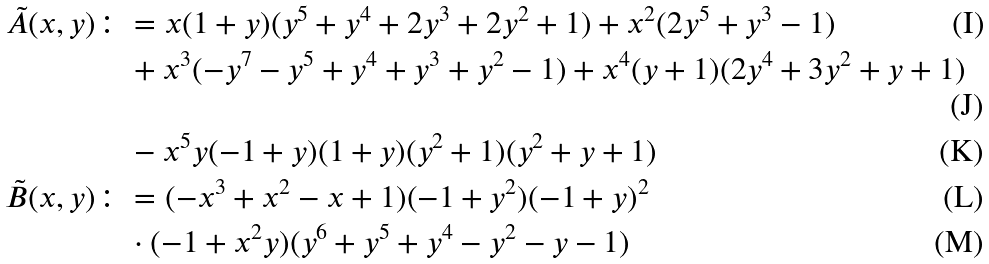Convert formula to latex. <formula><loc_0><loc_0><loc_500><loc_500>\tilde { A } ( x , y ) & \colon = x ( 1 + y ) ( y ^ { 5 } + y ^ { 4 } + 2 y ^ { 3 } + 2 y ^ { 2 } + 1 ) + x ^ { 2 } ( 2 y ^ { 5 } + y ^ { 3 } - 1 ) \\ & \quad + x ^ { 3 } ( - y ^ { 7 } - y ^ { 5 } + y ^ { 4 } + y ^ { 3 } + y ^ { 2 } - 1 ) + x ^ { 4 } ( y + 1 ) ( 2 y ^ { 4 } + 3 y ^ { 2 } + y + 1 ) \\ & \quad - x ^ { 5 } y ( - 1 + y ) ( 1 + y ) ( y ^ { 2 } + 1 ) ( y ^ { 2 } + y + 1 ) \\ \tilde { B } ( x , y ) & \colon = ( - x ^ { 3 } + x ^ { 2 } - x + 1 ) ( - 1 + y ^ { 2 } ) ( - 1 + y ) ^ { 2 } \\ & \quad \cdot ( - 1 + x ^ { 2 } y ) ( y ^ { 6 } + y ^ { 5 } + y ^ { 4 } - y ^ { 2 } - y - 1 )</formula> 